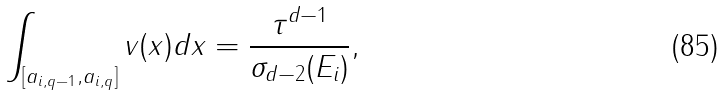Convert formula to latex. <formula><loc_0><loc_0><loc_500><loc_500>\int _ { [ a _ { i , q - 1 } , a _ { i , q } ] } v ( x ) d x = \frac { \tau ^ { d - 1 } } { \sigma _ { d - 2 } ( E _ { i } ) } ,</formula> 